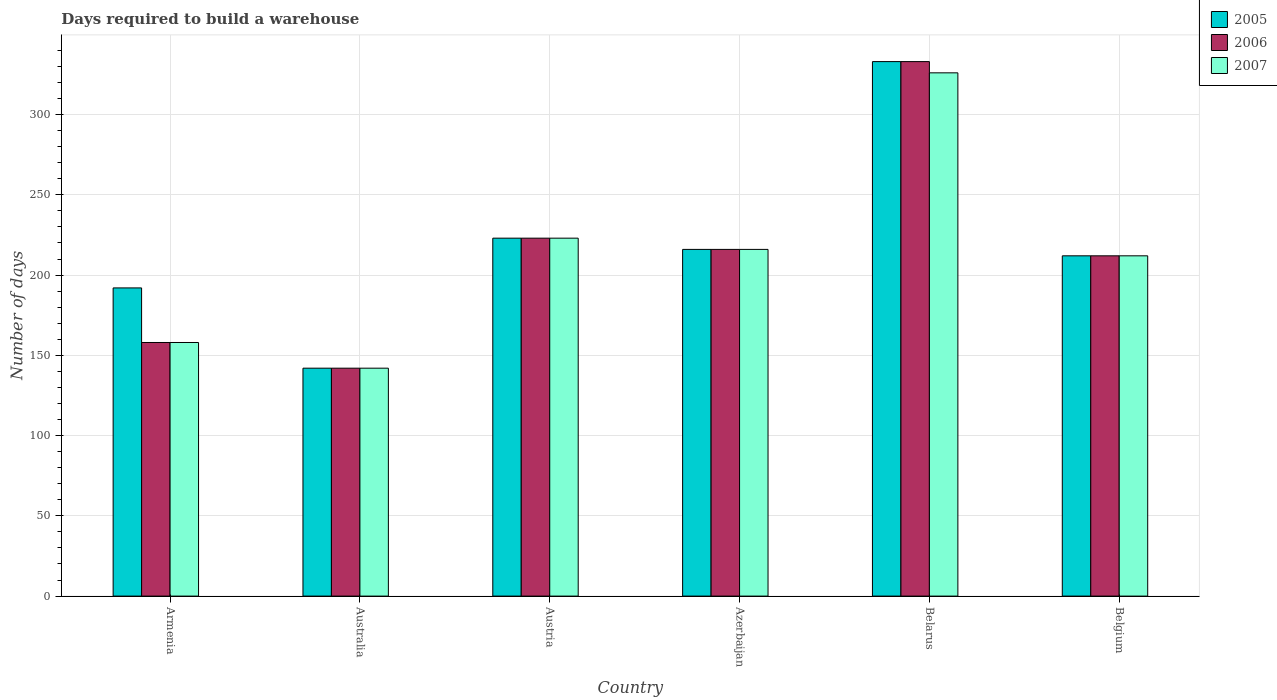Are the number of bars per tick equal to the number of legend labels?
Provide a short and direct response. Yes. In how many cases, is the number of bars for a given country not equal to the number of legend labels?
Ensure brevity in your answer.  0. What is the days required to build a warehouse in in 2006 in Armenia?
Make the answer very short. 158. Across all countries, what is the maximum days required to build a warehouse in in 2005?
Provide a short and direct response. 333. Across all countries, what is the minimum days required to build a warehouse in in 2007?
Your answer should be very brief. 142. In which country was the days required to build a warehouse in in 2006 maximum?
Provide a short and direct response. Belarus. In which country was the days required to build a warehouse in in 2006 minimum?
Ensure brevity in your answer.  Australia. What is the total days required to build a warehouse in in 2007 in the graph?
Your answer should be very brief. 1277. What is the difference between the days required to build a warehouse in in 2007 in Australia and that in Azerbaijan?
Your answer should be very brief. -74. What is the difference between the days required to build a warehouse in in 2005 in Belgium and the days required to build a warehouse in in 2007 in Australia?
Your answer should be compact. 70. What is the average days required to build a warehouse in in 2007 per country?
Provide a succinct answer. 212.83. In how many countries, is the days required to build a warehouse in in 2005 greater than 30 days?
Your answer should be very brief. 6. What is the ratio of the days required to build a warehouse in in 2006 in Armenia to that in Belarus?
Provide a succinct answer. 0.47. Is the days required to build a warehouse in in 2007 in Azerbaijan less than that in Belarus?
Your answer should be very brief. Yes. What is the difference between the highest and the second highest days required to build a warehouse in in 2007?
Give a very brief answer. -110. What is the difference between the highest and the lowest days required to build a warehouse in in 2006?
Provide a succinct answer. 191. In how many countries, is the days required to build a warehouse in in 2005 greater than the average days required to build a warehouse in in 2005 taken over all countries?
Your response must be concise. 2. What does the 3rd bar from the right in Azerbaijan represents?
Make the answer very short. 2005. How many bars are there?
Provide a succinct answer. 18. How many countries are there in the graph?
Make the answer very short. 6. Does the graph contain any zero values?
Ensure brevity in your answer.  No. Does the graph contain grids?
Provide a succinct answer. Yes. Where does the legend appear in the graph?
Ensure brevity in your answer.  Top right. How many legend labels are there?
Offer a very short reply. 3. What is the title of the graph?
Keep it short and to the point. Days required to build a warehouse. What is the label or title of the X-axis?
Ensure brevity in your answer.  Country. What is the label or title of the Y-axis?
Offer a very short reply. Number of days. What is the Number of days of 2005 in Armenia?
Your answer should be compact. 192. What is the Number of days in 2006 in Armenia?
Offer a terse response. 158. What is the Number of days in 2007 in Armenia?
Keep it short and to the point. 158. What is the Number of days in 2005 in Australia?
Your response must be concise. 142. What is the Number of days of 2006 in Australia?
Your answer should be compact. 142. What is the Number of days of 2007 in Australia?
Keep it short and to the point. 142. What is the Number of days of 2005 in Austria?
Give a very brief answer. 223. What is the Number of days of 2006 in Austria?
Offer a very short reply. 223. What is the Number of days in 2007 in Austria?
Ensure brevity in your answer.  223. What is the Number of days in 2005 in Azerbaijan?
Your answer should be very brief. 216. What is the Number of days in 2006 in Azerbaijan?
Keep it short and to the point. 216. What is the Number of days of 2007 in Azerbaijan?
Offer a terse response. 216. What is the Number of days in 2005 in Belarus?
Offer a terse response. 333. What is the Number of days of 2006 in Belarus?
Provide a succinct answer. 333. What is the Number of days of 2007 in Belarus?
Provide a short and direct response. 326. What is the Number of days in 2005 in Belgium?
Your answer should be compact. 212. What is the Number of days in 2006 in Belgium?
Keep it short and to the point. 212. What is the Number of days of 2007 in Belgium?
Keep it short and to the point. 212. Across all countries, what is the maximum Number of days in 2005?
Provide a short and direct response. 333. Across all countries, what is the maximum Number of days in 2006?
Make the answer very short. 333. Across all countries, what is the maximum Number of days in 2007?
Make the answer very short. 326. Across all countries, what is the minimum Number of days in 2005?
Provide a short and direct response. 142. Across all countries, what is the minimum Number of days in 2006?
Your answer should be compact. 142. Across all countries, what is the minimum Number of days of 2007?
Your answer should be compact. 142. What is the total Number of days in 2005 in the graph?
Offer a very short reply. 1318. What is the total Number of days in 2006 in the graph?
Provide a succinct answer. 1284. What is the total Number of days in 2007 in the graph?
Make the answer very short. 1277. What is the difference between the Number of days in 2006 in Armenia and that in Australia?
Make the answer very short. 16. What is the difference between the Number of days of 2005 in Armenia and that in Austria?
Give a very brief answer. -31. What is the difference between the Number of days in 2006 in Armenia and that in Austria?
Provide a succinct answer. -65. What is the difference between the Number of days of 2007 in Armenia and that in Austria?
Your answer should be compact. -65. What is the difference between the Number of days of 2006 in Armenia and that in Azerbaijan?
Provide a short and direct response. -58. What is the difference between the Number of days of 2007 in Armenia and that in Azerbaijan?
Provide a succinct answer. -58. What is the difference between the Number of days of 2005 in Armenia and that in Belarus?
Ensure brevity in your answer.  -141. What is the difference between the Number of days in 2006 in Armenia and that in Belarus?
Your answer should be compact. -175. What is the difference between the Number of days of 2007 in Armenia and that in Belarus?
Offer a terse response. -168. What is the difference between the Number of days of 2005 in Armenia and that in Belgium?
Provide a succinct answer. -20. What is the difference between the Number of days in 2006 in Armenia and that in Belgium?
Offer a very short reply. -54. What is the difference between the Number of days of 2007 in Armenia and that in Belgium?
Make the answer very short. -54. What is the difference between the Number of days in 2005 in Australia and that in Austria?
Your answer should be compact. -81. What is the difference between the Number of days of 2006 in Australia and that in Austria?
Your answer should be compact. -81. What is the difference between the Number of days in 2007 in Australia and that in Austria?
Offer a very short reply. -81. What is the difference between the Number of days of 2005 in Australia and that in Azerbaijan?
Ensure brevity in your answer.  -74. What is the difference between the Number of days in 2006 in Australia and that in Azerbaijan?
Make the answer very short. -74. What is the difference between the Number of days in 2007 in Australia and that in Azerbaijan?
Offer a terse response. -74. What is the difference between the Number of days of 2005 in Australia and that in Belarus?
Ensure brevity in your answer.  -191. What is the difference between the Number of days in 2006 in Australia and that in Belarus?
Give a very brief answer. -191. What is the difference between the Number of days of 2007 in Australia and that in Belarus?
Provide a short and direct response. -184. What is the difference between the Number of days in 2005 in Australia and that in Belgium?
Your response must be concise. -70. What is the difference between the Number of days in 2006 in Australia and that in Belgium?
Your answer should be compact. -70. What is the difference between the Number of days of 2007 in Australia and that in Belgium?
Keep it short and to the point. -70. What is the difference between the Number of days in 2005 in Austria and that in Azerbaijan?
Ensure brevity in your answer.  7. What is the difference between the Number of days of 2006 in Austria and that in Azerbaijan?
Provide a succinct answer. 7. What is the difference between the Number of days of 2005 in Austria and that in Belarus?
Your response must be concise. -110. What is the difference between the Number of days of 2006 in Austria and that in Belarus?
Give a very brief answer. -110. What is the difference between the Number of days of 2007 in Austria and that in Belarus?
Provide a succinct answer. -103. What is the difference between the Number of days of 2006 in Austria and that in Belgium?
Provide a succinct answer. 11. What is the difference between the Number of days of 2005 in Azerbaijan and that in Belarus?
Your answer should be compact. -117. What is the difference between the Number of days of 2006 in Azerbaijan and that in Belarus?
Ensure brevity in your answer.  -117. What is the difference between the Number of days of 2007 in Azerbaijan and that in Belarus?
Your answer should be very brief. -110. What is the difference between the Number of days of 2005 in Azerbaijan and that in Belgium?
Offer a terse response. 4. What is the difference between the Number of days of 2007 in Azerbaijan and that in Belgium?
Give a very brief answer. 4. What is the difference between the Number of days of 2005 in Belarus and that in Belgium?
Provide a short and direct response. 121. What is the difference between the Number of days in 2006 in Belarus and that in Belgium?
Offer a terse response. 121. What is the difference between the Number of days of 2007 in Belarus and that in Belgium?
Make the answer very short. 114. What is the difference between the Number of days in 2006 in Armenia and the Number of days in 2007 in Australia?
Provide a short and direct response. 16. What is the difference between the Number of days of 2005 in Armenia and the Number of days of 2006 in Austria?
Provide a short and direct response. -31. What is the difference between the Number of days of 2005 in Armenia and the Number of days of 2007 in Austria?
Give a very brief answer. -31. What is the difference between the Number of days of 2006 in Armenia and the Number of days of 2007 in Austria?
Your answer should be compact. -65. What is the difference between the Number of days in 2005 in Armenia and the Number of days in 2006 in Azerbaijan?
Offer a terse response. -24. What is the difference between the Number of days of 2005 in Armenia and the Number of days of 2007 in Azerbaijan?
Ensure brevity in your answer.  -24. What is the difference between the Number of days of 2006 in Armenia and the Number of days of 2007 in Azerbaijan?
Offer a very short reply. -58. What is the difference between the Number of days of 2005 in Armenia and the Number of days of 2006 in Belarus?
Provide a short and direct response. -141. What is the difference between the Number of days in 2005 in Armenia and the Number of days in 2007 in Belarus?
Offer a terse response. -134. What is the difference between the Number of days of 2006 in Armenia and the Number of days of 2007 in Belarus?
Offer a terse response. -168. What is the difference between the Number of days of 2005 in Armenia and the Number of days of 2006 in Belgium?
Offer a very short reply. -20. What is the difference between the Number of days of 2006 in Armenia and the Number of days of 2007 in Belgium?
Keep it short and to the point. -54. What is the difference between the Number of days of 2005 in Australia and the Number of days of 2006 in Austria?
Keep it short and to the point. -81. What is the difference between the Number of days in 2005 in Australia and the Number of days in 2007 in Austria?
Your response must be concise. -81. What is the difference between the Number of days in 2006 in Australia and the Number of days in 2007 in Austria?
Provide a succinct answer. -81. What is the difference between the Number of days of 2005 in Australia and the Number of days of 2006 in Azerbaijan?
Provide a succinct answer. -74. What is the difference between the Number of days of 2005 in Australia and the Number of days of 2007 in Azerbaijan?
Your answer should be very brief. -74. What is the difference between the Number of days in 2006 in Australia and the Number of days in 2007 in Azerbaijan?
Give a very brief answer. -74. What is the difference between the Number of days of 2005 in Australia and the Number of days of 2006 in Belarus?
Ensure brevity in your answer.  -191. What is the difference between the Number of days in 2005 in Australia and the Number of days in 2007 in Belarus?
Keep it short and to the point. -184. What is the difference between the Number of days of 2006 in Australia and the Number of days of 2007 in Belarus?
Give a very brief answer. -184. What is the difference between the Number of days of 2005 in Australia and the Number of days of 2006 in Belgium?
Ensure brevity in your answer.  -70. What is the difference between the Number of days in 2005 in Australia and the Number of days in 2007 in Belgium?
Make the answer very short. -70. What is the difference between the Number of days in 2006 in Australia and the Number of days in 2007 in Belgium?
Make the answer very short. -70. What is the difference between the Number of days of 2005 in Austria and the Number of days of 2006 in Azerbaijan?
Your response must be concise. 7. What is the difference between the Number of days of 2006 in Austria and the Number of days of 2007 in Azerbaijan?
Your answer should be compact. 7. What is the difference between the Number of days of 2005 in Austria and the Number of days of 2006 in Belarus?
Your answer should be very brief. -110. What is the difference between the Number of days of 2005 in Austria and the Number of days of 2007 in Belarus?
Keep it short and to the point. -103. What is the difference between the Number of days of 2006 in Austria and the Number of days of 2007 in Belarus?
Provide a short and direct response. -103. What is the difference between the Number of days of 2005 in Austria and the Number of days of 2006 in Belgium?
Provide a short and direct response. 11. What is the difference between the Number of days of 2005 in Austria and the Number of days of 2007 in Belgium?
Offer a terse response. 11. What is the difference between the Number of days of 2005 in Azerbaijan and the Number of days of 2006 in Belarus?
Give a very brief answer. -117. What is the difference between the Number of days in 2005 in Azerbaijan and the Number of days in 2007 in Belarus?
Your response must be concise. -110. What is the difference between the Number of days of 2006 in Azerbaijan and the Number of days of 2007 in Belarus?
Give a very brief answer. -110. What is the difference between the Number of days of 2005 in Azerbaijan and the Number of days of 2006 in Belgium?
Offer a very short reply. 4. What is the difference between the Number of days in 2005 in Azerbaijan and the Number of days in 2007 in Belgium?
Give a very brief answer. 4. What is the difference between the Number of days in 2005 in Belarus and the Number of days in 2006 in Belgium?
Provide a succinct answer. 121. What is the difference between the Number of days of 2005 in Belarus and the Number of days of 2007 in Belgium?
Keep it short and to the point. 121. What is the difference between the Number of days of 2006 in Belarus and the Number of days of 2007 in Belgium?
Your answer should be compact. 121. What is the average Number of days of 2005 per country?
Give a very brief answer. 219.67. What is the average Number of days in 2006 per country?
Offer a very short reply. 214. What is the average Number of days in 2007 per country?
Provide a succinct answer. 212.83. What is the difference between the Number of days of 2006 and Number of days of 2007 in Armenia?
Keep it short and to the point. 0. What is the difference between the Number of days of 2005 and Number of days of 2006 in Australia?
Keep it short and to the point. 0. What is the difference between the Number of days of 2005 and Number of days of 2007 in Australia?
Offer a terse response. 0. What is the difference between the Number of days of 2006 and Number of days of 2007 in Australia?
Your answer should be very brief. 0. What is the difference between the Number of days in 2005 and Number of days in 2006 in Austria?
Make the answer very short. 0. What is the difference between the Number of days in 2006 and Number of days in 2007 in Austria?
Your answer should be very brief. 0. What is the difference between the Number of days of 2005 and Number of days of 2007 in Azerbaijan?
Provide a short and direct response. 0. What is the difference between the Number of days of 2006 and Number of days of 2007 in Azerbaijan?
Your answer should be compact. 0. What is the difference between the Number of days of 2006 and Number of days of 2007 in Belarus?
Provide a short and direct response. 7. What is the difference between the Number of days of 2005 and Number of days of 2006 in Belgium?
Your answer should be compact. 0. What is the difference between the Number of days of 2005 and Number of days of 2007 in Belgium?
Make the answer very short. 0. What is the ratio of the Number of days in 2005 in Armenia to that in Australia?
Keep it short and to the point. 1.35. What is the ratio of the Number of days of 2006 in Armenia to that in Australia?
Offer a very short reply. 1.11. What is the ratio of the Number of days in 2007 in Armenia to that in Australia?
Your answer should be very brief. 1.11. What is the ratio of the Number of days in 2005 in Armenia to that in Austria?
Provide a succinct answer. 0.86. What is the ratio of the Number of days in 2006 in Armenia to that in Austria?
Give a very brief answer. 0.71. What is the ratio of the Number of days in 2007 in Armenia to that in Austria?
Offer a terse response. 0.71. What is the ratio of the Number of days in 2005 in Armenia to that in Azerbaijan?
Ensure brevity in your answer.  0.89. What is the ratio of the Number of days of 2006 in Armenia to that in Azerbaijan?
Your answer should be very brief. 0.73. What is the ratio of the Number of days of 2007 in Armenia to that in Azerbaijan?
Your answer should be very brief. 0.73. What is the ratio of the Number of days of 2005 in Armenia to that in Belarus?
Offer a very short reply. 0.58. What is the ratio of the Number of days of 2006 in Armenia to that in Belarus?
Offer a terse response. 0.47. What is the ratio of the Number of days of 2007 in Armenia to that in Belarus?
Provide a succinct answer. 0.48. What is the ratio of the Number of days of 2005 in Armenia to that in Belgium?
Ensure brevity in your answer.  0.91. What is the ratio of the Number of days of 2006 in Armenia to that in Belgium?
Your answer should be compact. 0.75. What is the ratio of the Number of days in 2007 in Armenia to that in Belgium?
Make the answer very short. 0.75. What is the ratio of the Number of days in 2005 in Australia to that in Austria?
Your answer should be very brief. 0.64. What is the ratio of the Number of days of 2006 in Australia to that in Austria?
Ensure brevity in your answer.  0.64. What is the ratio of the Number of days of 2007 in Australia to that in Austria?
Your response must be concise. 0.64. What is the ratio of the Number of days of 2005 in Australia to that in Azerbaijan?
Offer a terse response. 0.66. What is the ratio of the Number of days in 2006 in Australia to that in Azerbaijan?
Your answer should be very brief. 0.66. What is the ratio of the Number of days of 2007 in Australia to that in Azerbaijan?
Give a very brief answer. 0.66. What is the ratio of the Number of days in 2005 in Australia to that in Belarus?
Your answer should be compact. 0.43. What is the ratio of the Number of days of 2006 in Australia to that in Belarus?
Offer a terse response. 0.43. What is the ratio of the Number of days of 2007 in Australia to that in Belarus?
Give a very brief answer. 0.44. What is the ratio of the Number of days of 2005 in Australia to that in Belgium?
Provide a succinct answer. 0.67. What is the ratio of the Number of days in 2006 in Australia to that in Belgium?
Keep it short and to the point. 0.67. What is the ratio of the Number of days in 2007 in Australia to that in Belgium?
Provide a short and direct response. 0.67. What is the ratio of the Number of days in 2005 in Austria to that in Azerbaijan?
Your response must be concise. 1.03. What is the ratio of the Number of days in 2006 in Austria to that in Azerbaijan?
Offer a terse response. 1.03. What is the ratio of the Number of days of 2007 in Austria to that in Azerbaijan?
Your response must be concise. 1.03. What is the ratio of the Number of days of 2005 in Austria to that in Belarus?
Your response must be concise. 0.67. What is the ratio of the Number of days of 2006 in Austria to that in Belarus?
Your answer should be compact. 0.67. What is the ratio of the Number of days of 2007 in Austria to that in Belarus?
Keep it short and to the point. 0.68. What is the ratio of the Number of days of 2005 in Austria to that in Belgium?
Your answer should be very brief. 1.05. What is the ratio of the Number of days in 2006 in Austria to that in Belgium?
Offer a very short reply. 1.05. What is the ratio of the Number of days of 2007 in Austria to that in Belgium?
Offer a very short reply. 1.05. What is the ratio of the Number of days of 2005 in Azerbaijan to that in Belarus?
Offer a terse response. 0.65. What is the ratio of the Number of days of 2006 in Azerbaijan to that in Belarus?
Offer a terse response. 0.65. What is the ratio of the Number of days of 2007 in Azerbaijan to that in Belarus?
Offer a terse response. 0.66. What is the ratio of the Number of days of 2005 in Azerbaijan to that in Belgium?
Make the answer very short. 1.02. What is the ratio of the Number of days of 2006 in Azerbaijan to that in Belgium?
Give a very brief answer. 1.02. What is the ratio of the Number of days in 2007 in Azerbaijan to that in Belgium?
Offer a terse response. 1.02. What is the ratio of the Number of days in 2005 in Belarus to that in Belgium?
Ensure brevity in your answer.  1.57. What is the ratio of the Number of days in 2006 in Belarus to that in Belgium?
Provide a succinct answer. 1.57. What is the ratio of the Number of days of 2007 in Belarus to that in Belgium?
Ensure brevity in your answer.  1.54. What is the difference between the highest and the second highest Number of days of 2005?
Your answer should be very brief. 110. What is the difference between the highest and the second highest Number of days of 2006?
Provide a succinct answer. 110. What is the difference between the highest and the second highest Number of days in 2007?
Your answer should be compact. 103. What is the difference between the highest and the lowest Number of days in 2005?
Provide a succinct answer. 191. What is the difference between the highest and the lowest Number of days of 2006?
Provide a succinct answer. 191. What is the difference between the highest and the lowest Number of days of 2007?
Provide a succinct answer. 184. 